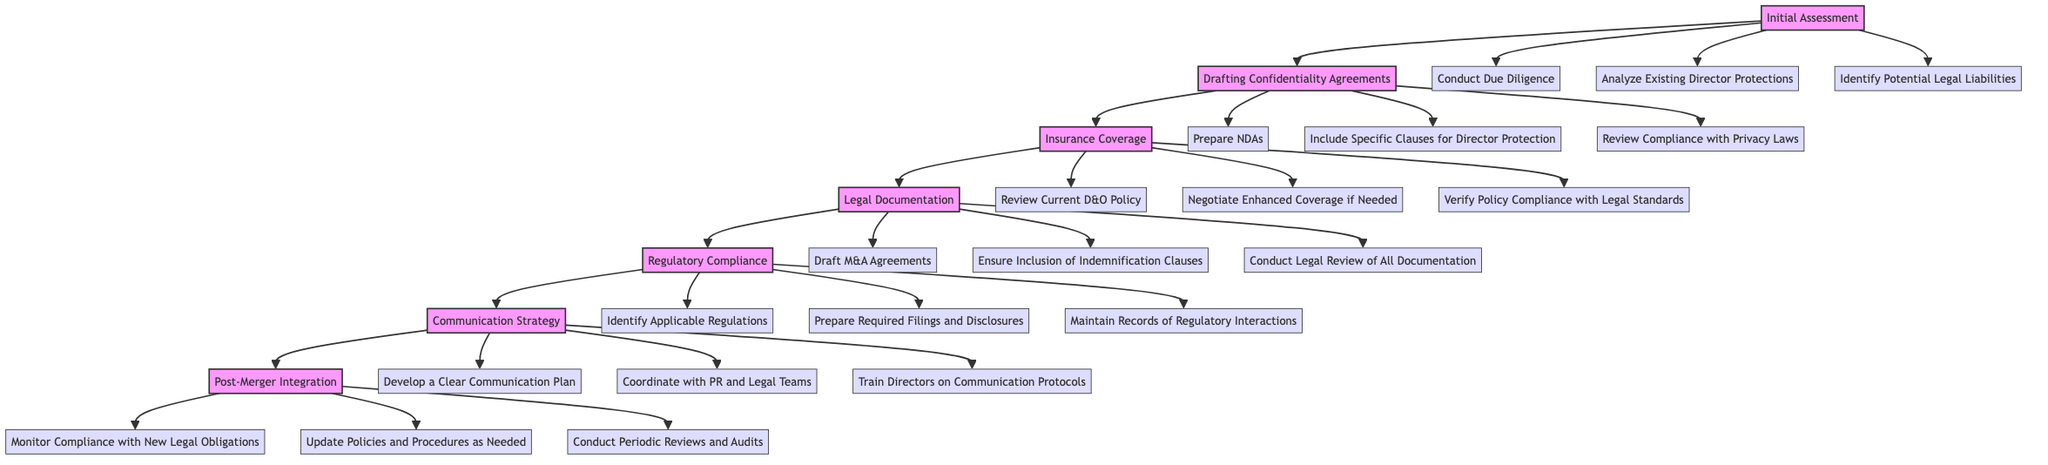What is the first step in the diagram? The first step in the diagram is labeled "Initial Assessment," which is the starting point of the process outlined.
Answer: Initial Assessment How many main steps are there in the diagram? The diagram contains a total of six main steps, which are connected in a linear fashion.
Answer: 6 What substep follows "Drafting Confidentiality Agreements"? The substep that follows "Drafting Confidentiality Agreements" is "Insurance Coverage." This progression indicates the flow of actions required.
Answer: Insurance Coverage Which step includes "Maintain Records of Regulatory Interactions"? "Maintain Records of Regulatory Interactions" is included under the step "Regulatory Compliance," representing one of the key actions in ensuring legal adherence.
Answer: Regulatory Compliance What are the three substeps under "Post-Merger Integration"? The three substeps under "Post-Merger Integration" are "Monitor Compliance with New Legal Obligations," "Update Policies and Procedures as Needed," and "Conduct Periodic Reviews and Audits," which help ensure ongoing compliance.
Answer: Monitor Compliance with New Legal Obligations, Update Policies and Procedures as Needed, Conduct Periodic Reviews and Audits How do "Communication Strategy" and "Legal Documentation" relate to each other in the diagram? "Communication Strategy" follows "Regulatory Compliance," while "Legal Documentation" directly precedes it, demonstrating the process of ensuring legal protections involves communication planning after documenting legal requirements.
Answer: They are sequential steps in the process Which step has the most substeps? The step "Drafting Confidentiality Agreements" has the most substeps, comprising a total of three different actions required under this step.
Answer: Drafting Confidentiality Agreements What is the last step in the diagram? The last step in the diagram is labeled "Post-Merger Integration," indicating the final actions to be taken for ongoing protections after the merger.
Answer: Post-Merger Integration What should be prepared according to the substep under "Insurance Coverage"? According to the substep under "Insurance Coverage," "Review Current D&O Policy" should be prepared, which involves assessing the current insurance policy to ensure adequate protection.
Answer: Review Current D&O Policy 